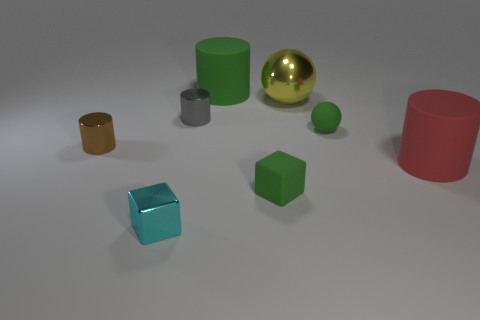Add 1 big cylinders. How many objects exist? 9 Subtract all blocks. How many objects are left? 6 Add 3 tiny cyan metallic objects. How many tiny cyan metallic objects are left? 4 Add 8 tiny gray things. How many tiny gray things exist? 9 Subtract 0 brown balls. How many objects are left? 8 Subtract all red rubber things. Subtract all red cylinders. How many objects are left? 6 